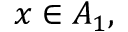<formula> <loc_0><loc_0><loc_500><loc_500>x \in A _ { 1 } ,</formula> 